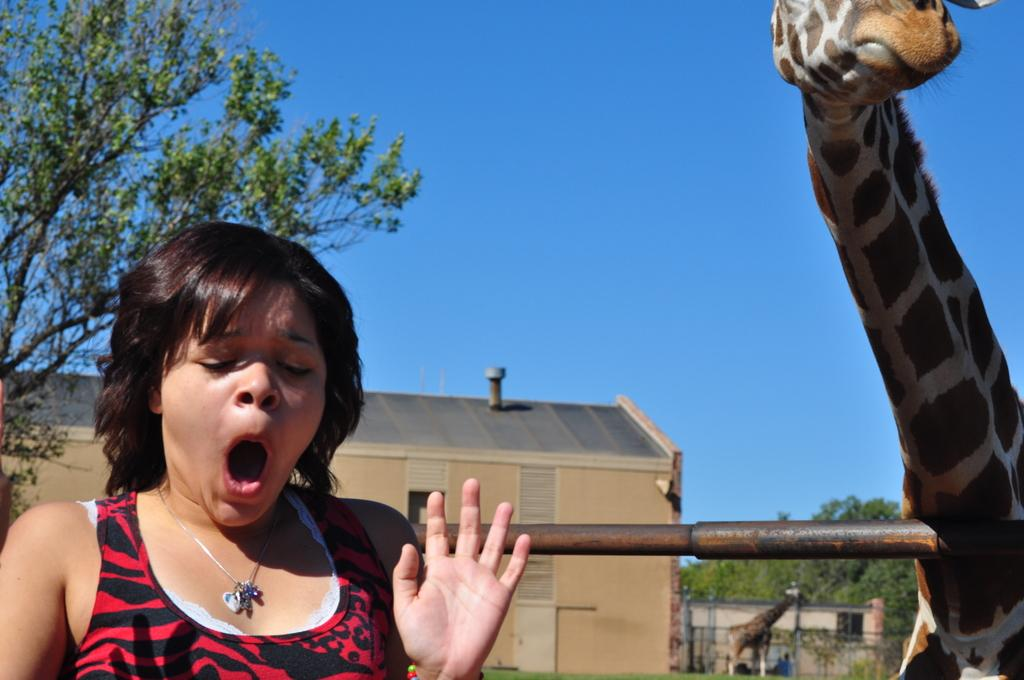Who or what is present in the image? There is a person in the image. What animals can be seen in the image? There are two giraffes in the image. What can be seen in the background of the image? There are buildings, trees, and the sky visible in the background of the image. What type of cherries are being dropped from the buildings in the image? There are no cherries or buildings dropping anything in the image; it features a person and two giraffes with a background of buildings, trees, and the sky. 